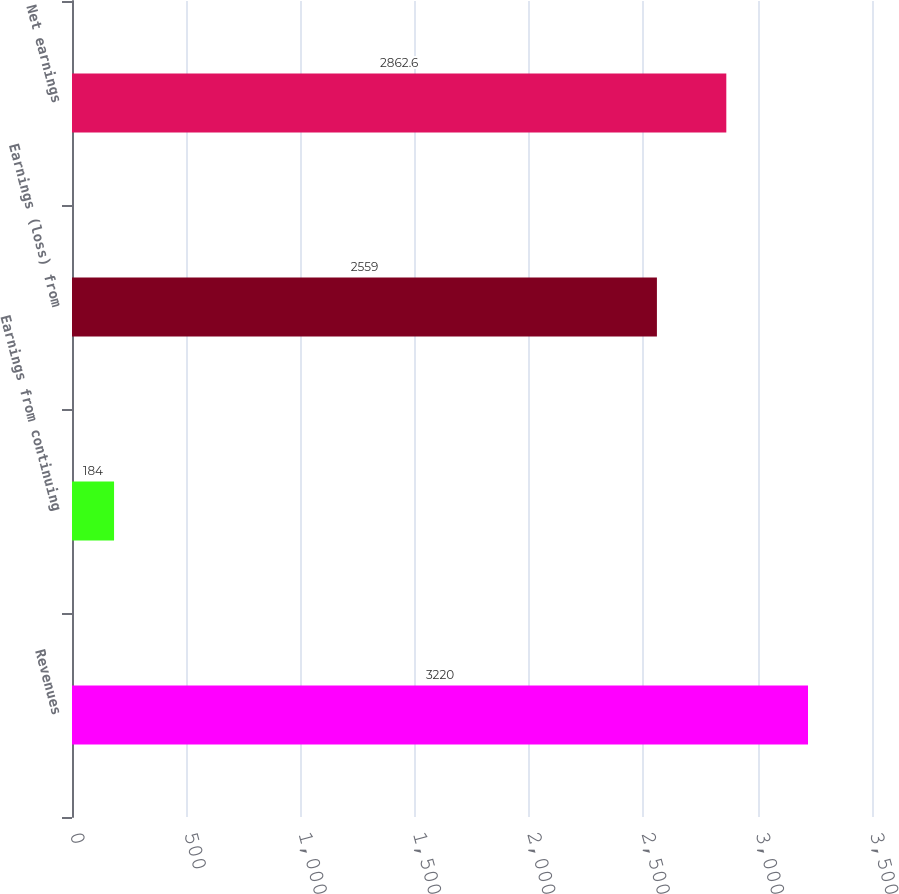Convert chart to OTSL. <chart><loc_0><loc_0><loc_500><loc_500><bar_chart><fcel>Revenues<fcel>Earnings from continuing<fcel>Earnings (loss) from<fcel>Net earnings<nl><fcel>3220<fcel>184<fcel>2559<fcel>2862.6<nl></chart> 